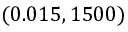<formula> <loc_0><loc_0><loc_500><loc_500>( 0 . 0 1 5 , 1 5 0 0 )</formula> 